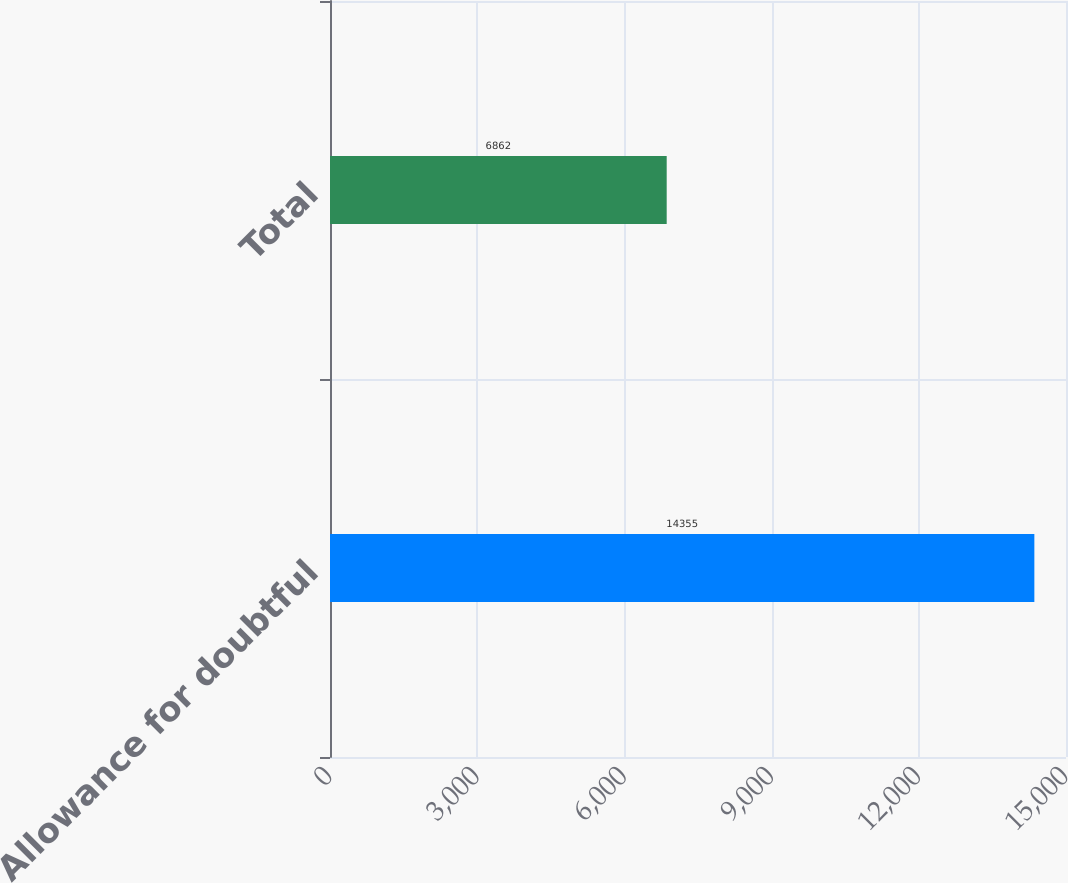Convert chart to OTSL. <chart><loc_0><loc_0><loc_500><loc_500><bar_chart><fcel>Allowance for doubtful<fcel>Total<nl><fcel>14355<fcel>6862<nl></chart> 